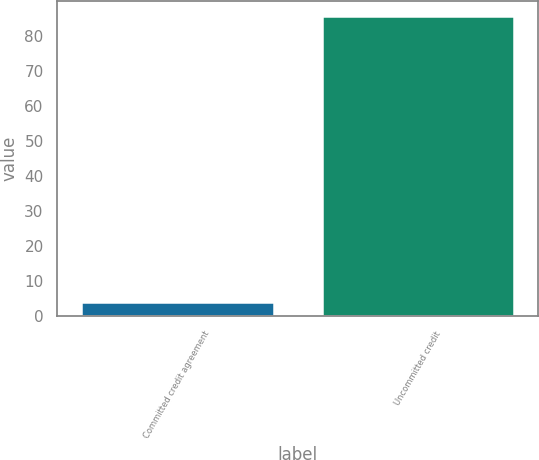Convert chart. <chart><loc_0><loc_0><loc_500><loc_500><bar_chart><fcel>Committed credit agreement<fcel>Uncommitted credit<nl><fcel>4.14<fcel>85.7<nl></chart> 